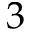<formula> <loc_0><loc_0><loc_500><loc_500>3</formula> 